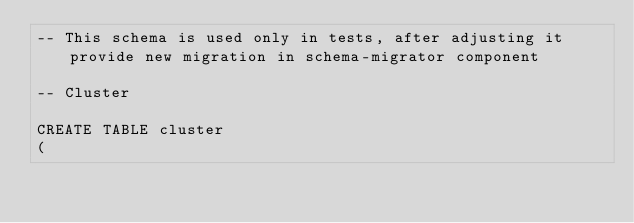<code> <loc_0><loc_0><loc_500><loc_500><_SQL_>-- This schema is used only in tests, after adjusting it provide new migration in schema-migrator component

-- Cluster

CREATE TABLE cluster
(</code> 